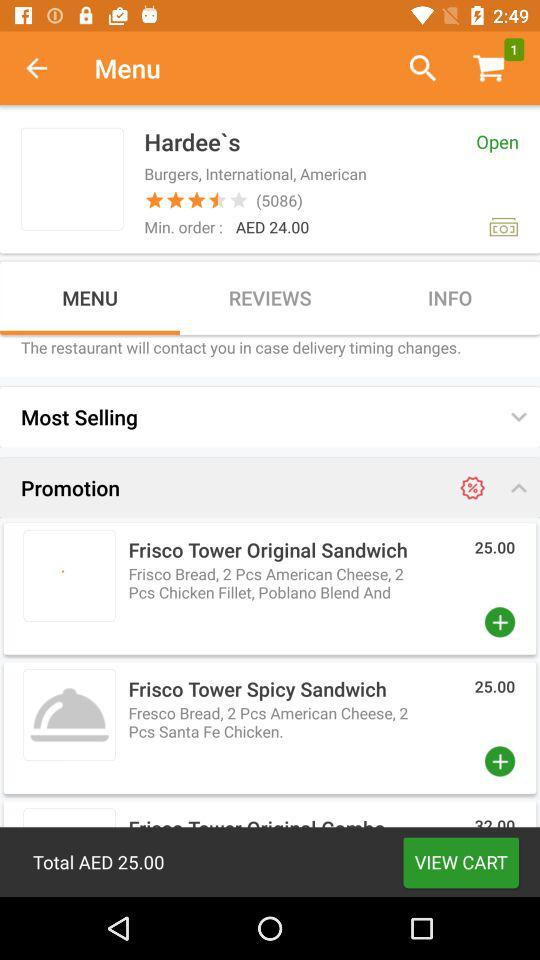How many items are there in the cart? There is 1 item in the cart. 